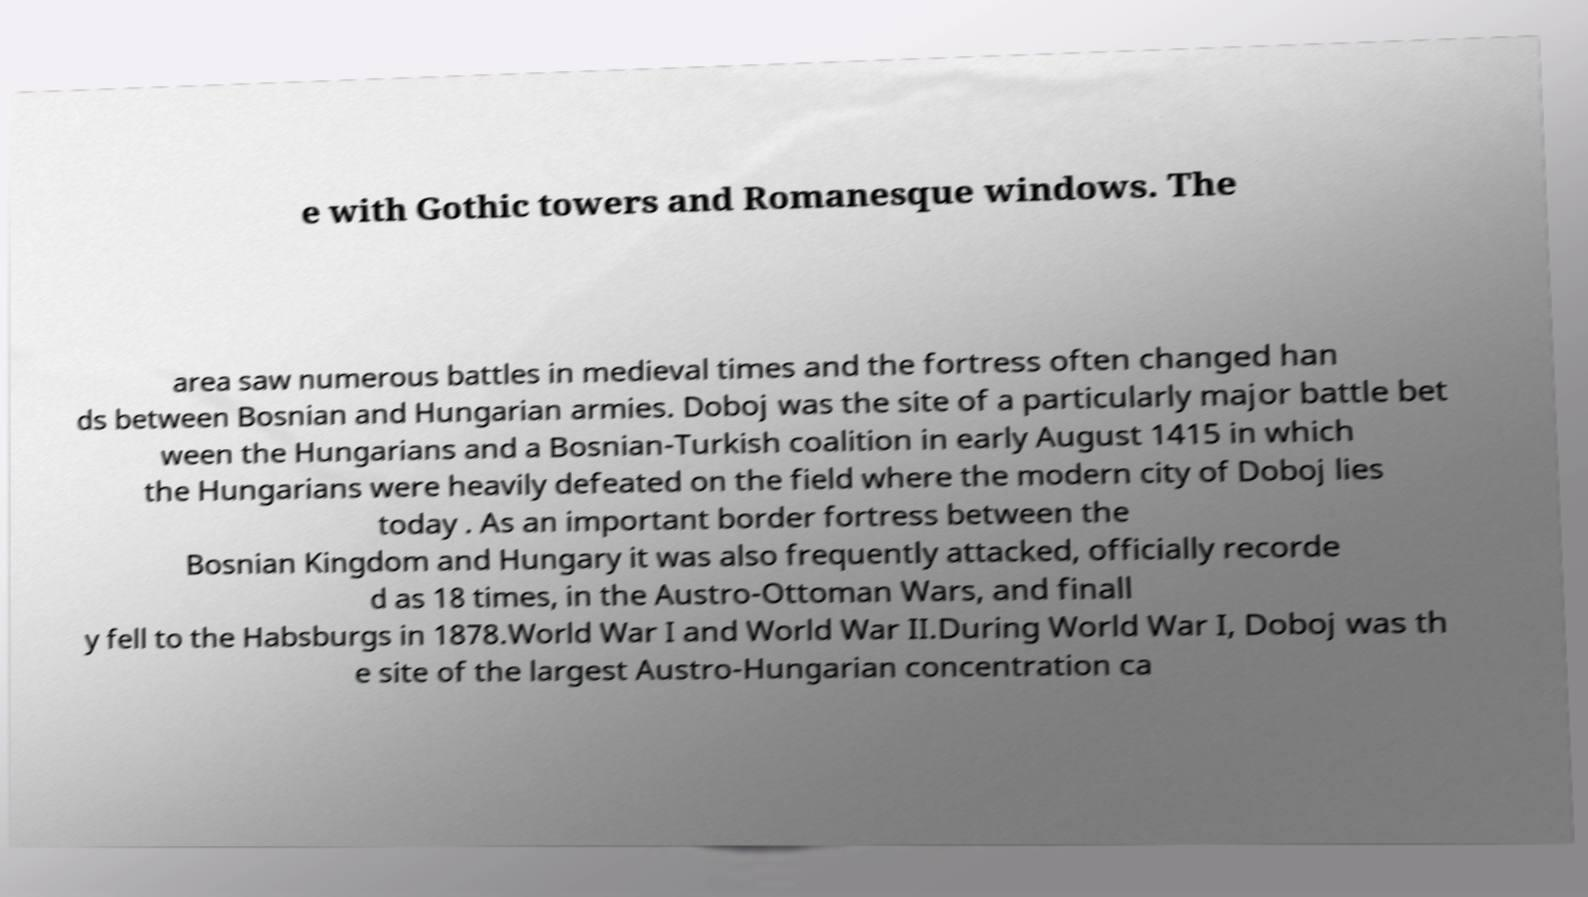For documentation purposes, I need the text within this image transcribed. Could you provide that? e with Gothic towers and Romanesque windows. The area saw numerous battles in medieval times and the fortress often changed han ds between Bosnian and Hungarian armies. Doboj was the site of a particularly major battle bet ween the Hungarians and a Bosnian-Turkish coalition in early August 1415 in which the Hungarians were heavily defeated on the field where the modern city of Doboj lies today . As an important border fortress between the Bosnian Kingdom and Hungary it was also frequently attacked, officially recorde d as 18 times, in the Austro-Ottoman Wars, and finall y fell to the Habsburgs in 1878.World War I and World War II.During World War I, Doboj was th e site of the largest Austro-Hungarian concentration ca 